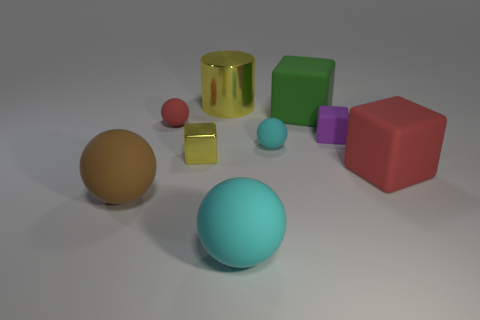Subtract all big cyan spheres. How many spheres are left? 3 Subtract all cylinders. How many objects are left? 8 Subtract 2 spheres. How many spheres are left? 2 Subtract all green spheres. Subtract all cyan cylinders. How many spheres are left? 4 Subtract all green cylinders. How many cyan balls are left? 2 Subtract all red spheres. How many spheres are left? 3 Subtract all big cyan metal cylinders. Subtract all big brown matte spheres. How many objects are left? 8 Add 1 red things. How many red things are left? 3 Add 5 purple things. How many purple things exist? 6 Subtract 0 gray cubes. How many objects are left? 9 